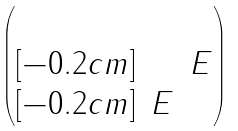Convert formula to latex. <formula><loc_0><loc_0><loc_500><loc_500>\begin{pmatrix} & & \\ [ - 0 . 2 c m ] & & E \\ [ - 0 . 2 c m ] & E & \end{pmatrix}</formula> 